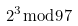Convert formula to latex. <formula><loc_0><loc_0><loc_500><loc_500>2 ^ { 3 } { \bmod { 9 } } 7</formula> 